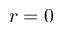<formula> <loc_0><loc_0><loc_500><loc_500>\boldsymbol r = 0</formula> 